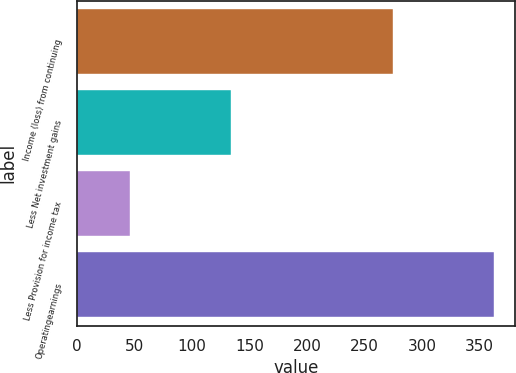Convert chart to OTSL. <chart><loc_0><loc_0><loc_500><loc_500><bar_chart><fcel>Income (loss) from continuing<fcel>Less Net investment gains<fcel>Less Provision for income tax<fcel>Operatingearnings<nl><fcel>275<fcel>134<fcel>46<fcel>363<nl></chart> 